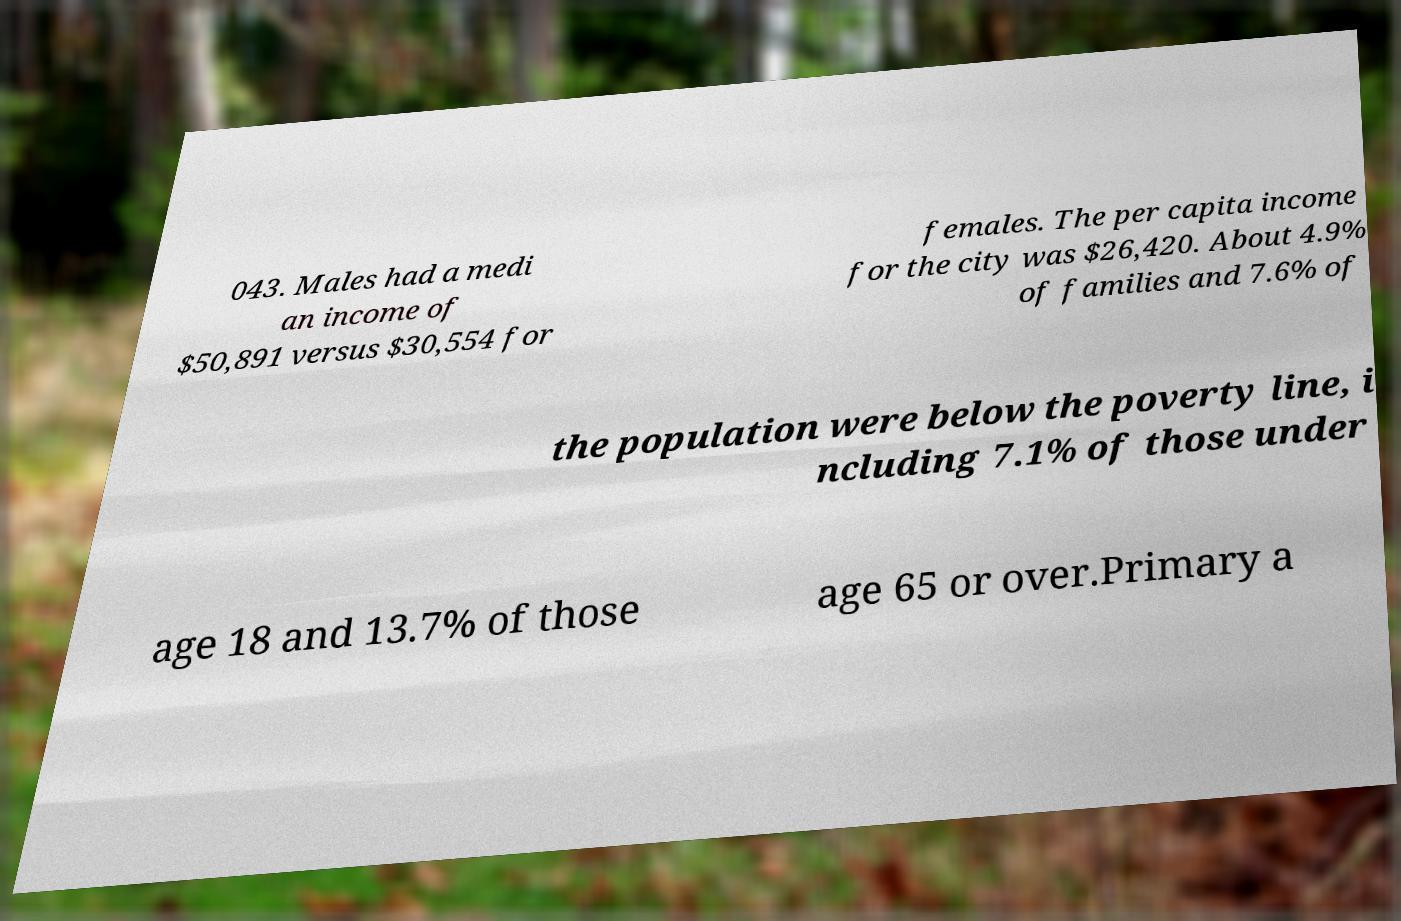Could you extract and type out the text from this image? 043. Males had a medi an income of $50,891 versus $30,554 for females. The per capita income for the city was $26,420. About 4.9% of families and 7.6% of the population were below the poverty line, i ncluding 7.1% of those under age 18 and 13.7% of those age 65 or over.Primary a 